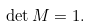<formula> <loc_0><loc_0><loc_500><loc_500>\det M = 1 .</formula> 